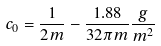Convert formula to latex. <formula><loc_0><loc_0><loc_500><loc_500>c _ { 0 } = \frac { 1 } { 2 m } - \frac { 1 . 8 8 } { 3 2 \pi m } \frac { g } { m ^ { 2 } }</formula> 